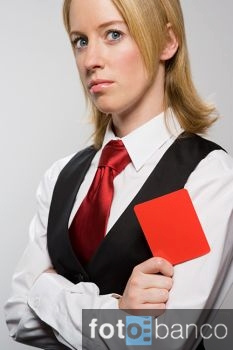Identify the text contained in this image. foto banco 